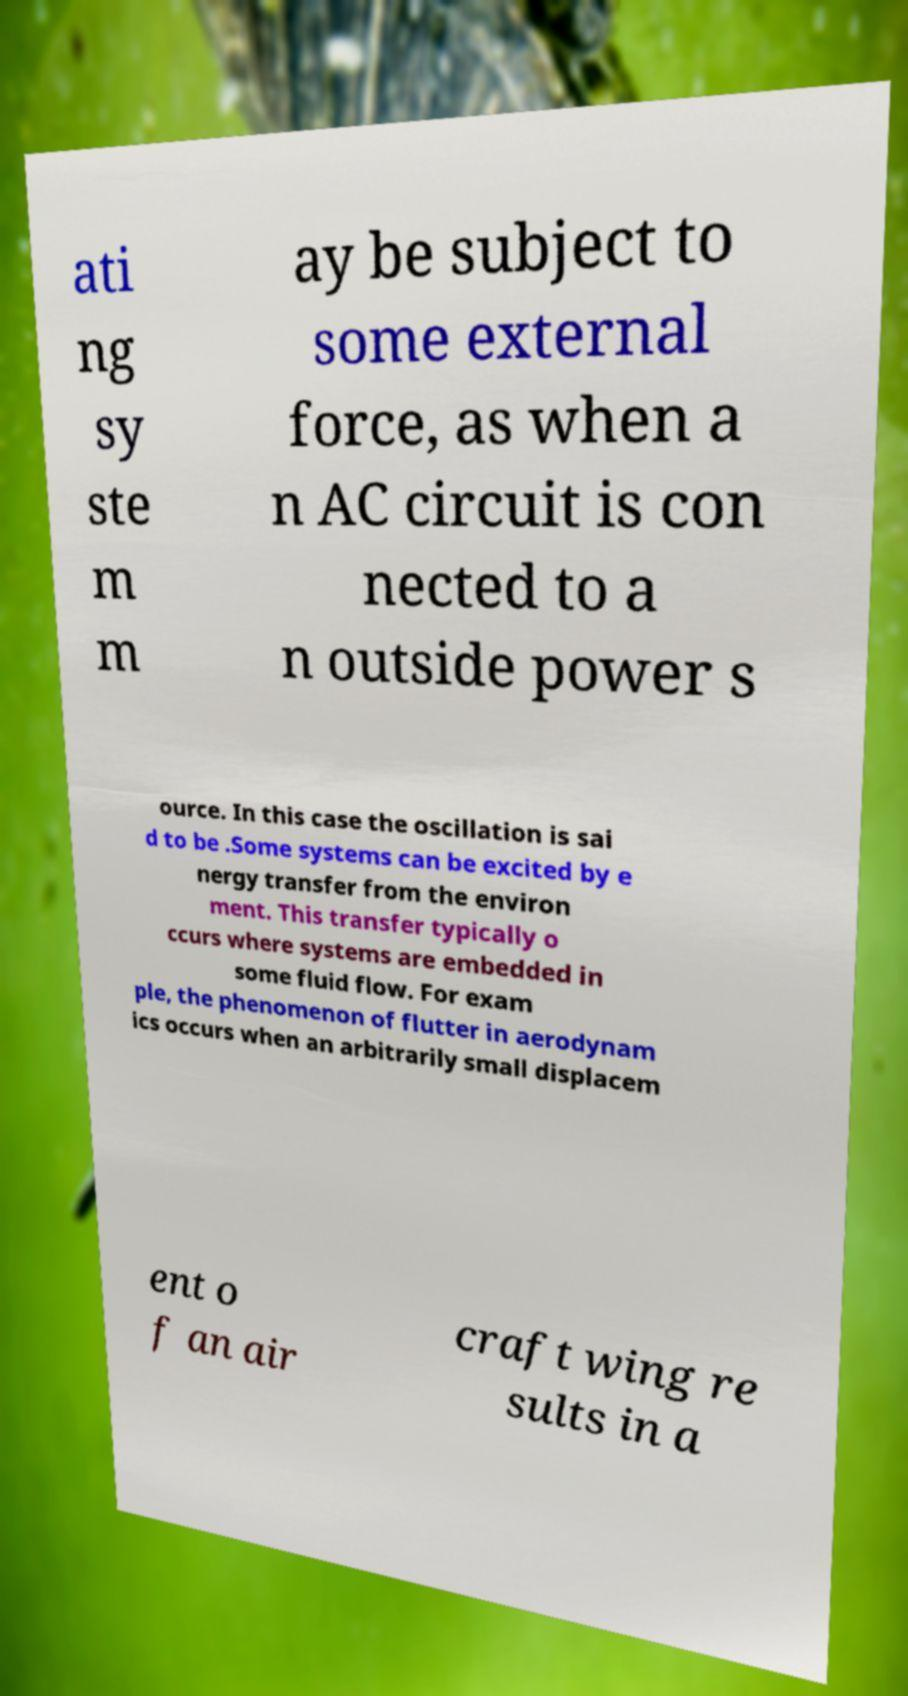I need the written content from this picture converted into text. Can you do that? ati ng sy ste m m ay be subject to some external force, as when a n AC circuit is con nected to a n outside power s ource. In this case the oscillation is sai d to be .Some systems can be excited by e nergy transfer from the environ ment. This transfer typically o ccurs where systems are embedded in some fluid flow. For exam ple, the phenomenon of flutter in aerodynam ics occurs when an arbitrarily small displacem ent o f an air craft wing re sults in a 